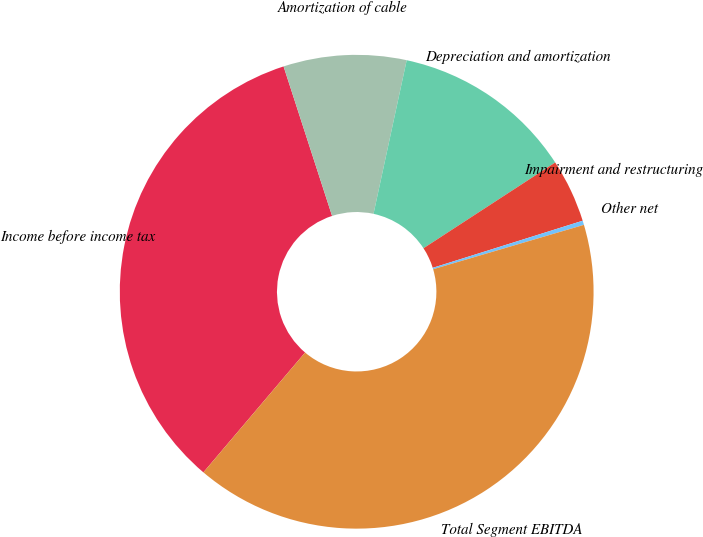Convert chart. <chart><loc_0><loc_0><loc_500><loc_500><pie_chart><fcel>Income before income tax<fcel>Amortization of cable<fcel>Depreciation and amortization<fcel>Impairment and restructuring<fcel>Other net<fcel>Total Segment EBITDA<nl><fcel>33.81%<fcel>8.38%<fcel>12.43%<fcel>4.34%<fcel>0.29%<fcel>40.76%<nl></chart> 